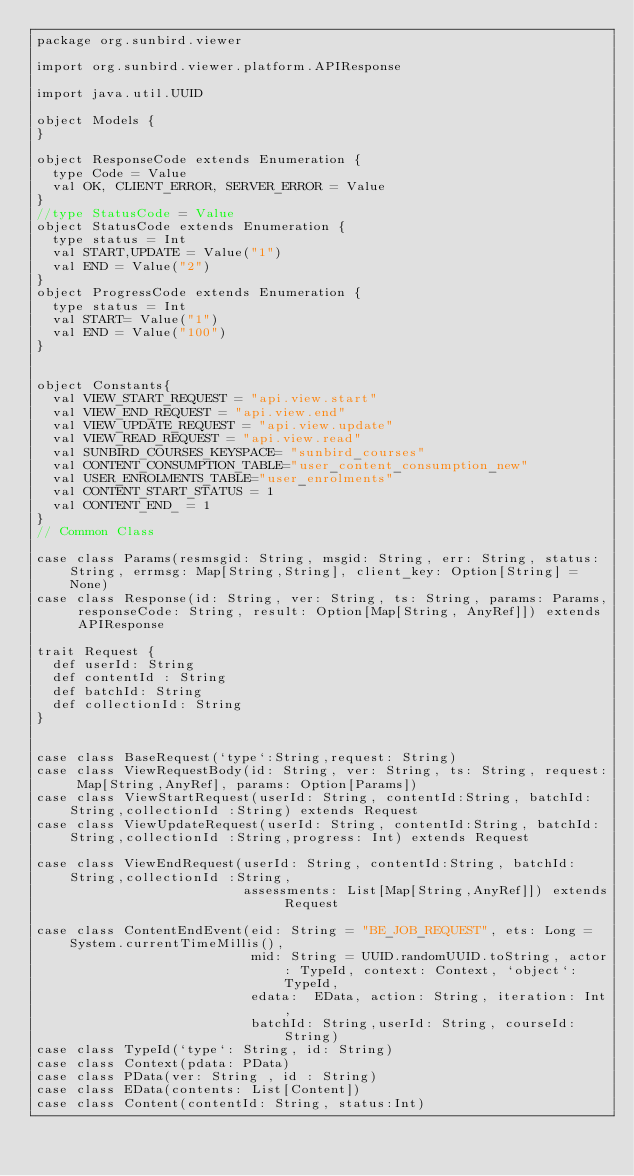Convert code to text. <code><loc_0><loc_0><loc_500><loc_500><_Scala_>package org.sunbird.viewer

import org.sunbird.viewer.platform.APIResponse

import java.util.UUID

object Models {
}

object ResponseCode extends Enumeration {
  type Code = Value
  val OK, CLIENT_ERROR, SERVER_ERROR = Value
}
//type StatusCode = Value
object StatusCode extends Enumeration {
  type status = Int
  val START,UPDATE = Value("1")
  val END = Value("2")
}
object ProgressCode extends Enumeration {
  type status = Int
  val START= Value("1")
  val END = Value("100")
}


object Constants{
  val VIEW_START_REQUEST = "api.view.start"
  val VIEW_END_REQUEST = "api.view.end"
  val VIEW_UPDATE_REQUEST = "api.view.update"
  val VIEW_READ_REQUEST = "api.view.read"
  val SUNBIRD_COURSES_KEYSPACE= "sunbird_courses"
  val CONTENT_CONSUMPTION_TABLE="user_content_consumption_new"
  val USER_ENROLMENTS_TABLE="user_enrolments"
  val CONTENT_START_STATUS = 1
  val CONTENT_END_ = 1
}
// Common Class

case class Params(resmsgid: String, msgid: String, err: String, status: String, errmsg: Map[String,String], client_key: Option[String] = None)
case class Response(id: String, ver: String, ts: String, params: Params, responseCode: String, result: Option[Map[String, AnyRef]]) extends APIResponse

trait Request {
  def userId: String
  def contentId : String
  def batchId: String
  def collectionId: String
}


case class BaseRequest(`type`:String,request: String)
case class ViewRequestBody(id: String, ver: String, ts: String, request: Map[String,AnyRef], params: Option[Params])
case class ViewStartRequest(userId: String, contentId:String, batchId:String,collectionId :String) extends Request
case class ViewUpdateRequest(userId: String, contentId:String, batchId:String,collectionId :String,progress: Int) extends Request

case class ViewEndRequest(userId: String, contentId:String, batchId:String,collectionId :String,
                          assessments: List[Map[String,AnyRef]]) extends Request

case class ContentEndEvent(eid: String = "BE_JOB_REQUEST", ets: Long = System.currentTimeMillis(),
                           mid: String = UUID.randomUUID.toString, actor: TypeId, context: Context, `object`: TypeId,
                           edata:  EData, action: String, iteration: Int,
                           batchId: String,userId: String, courseId: String)
case class TypeId(`type`: String, id: String)
case class Context(pdata: PData)
case class PData(ver: String , id : String)
case class EData(contents: List[Content])
case class Content(contentId: String, status:Int)
</code> 